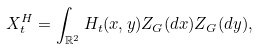Convert formula to latex. <formula><loc_0><loc_0><loc_500><loc_500>X ^ { H } _ { t } = \int _ { \mathbb { R } ^ { 2 } } H _ { t } ( x , y ) Z _ { G } ( d x ) Z _ { G } ( d y ) ,</formula> 